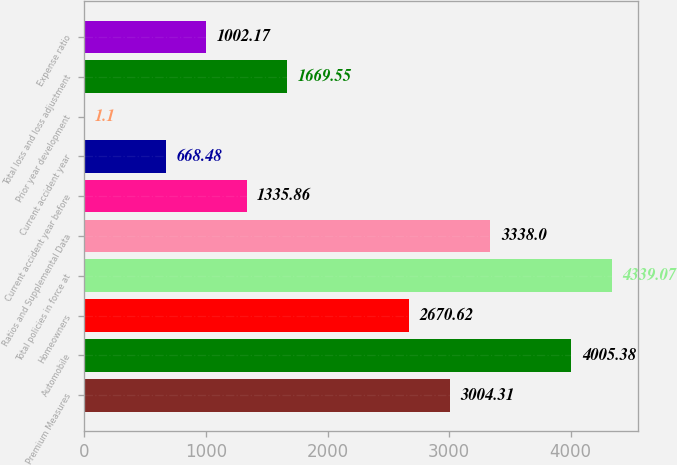Convert chart to OTSL. <chart><loc_0><loc_0><loc_500><loc_500><bar_chart><fcel>Premium Measures<fcel>Automobile<fcel>Homeowners<fcel>Total policies in force at<fcel>Ratios and Supplemental Data<fcel>Current accident year before<fcel>Current accident year<fcel>Prior year development<fcel>Total loss and loss adjustment<fcel>Expense ratio<nl><fcel>3004.31<fcel>4005.38<fcel>2670.62<fcel>4339.07<fcel>3338<fcel>1335.86<fcel>668.48<fcel>1.1<fcel>1669.55<fcel>1002.17<nl></chart> 